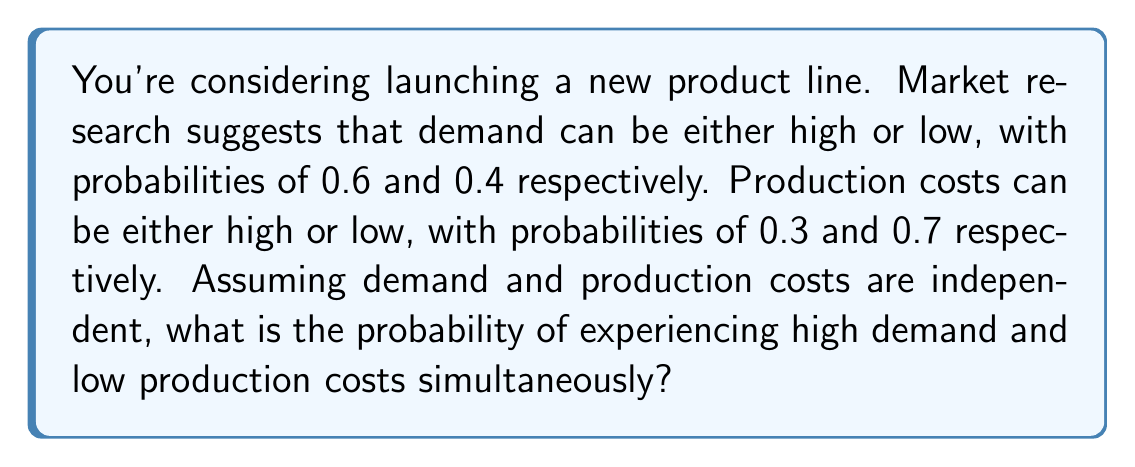Give your solution to this math problem. To solve this problem, we need to use the concept of joint probability for independent events. Let's approach this step-by-step:

1. Define the events:
   - Let H be the event of high demand
   - Let L be the event of low production costs

2. Given probabilities:
   - P(H) = 0.6 (probability of high demand)
   - P(L) = 0.7 (probability of low production costs)

3. Since the events are independent, the joint probability is the product of their individual probabilities:

   $$P(H \text{ and } L) = P(H) \times P(L)$$

4. Substitute the values:

   $$P(H \text{ and } L) = 0.6 \times 0.7$$

5. Calculate:

   $$P(H \text{ and } L) = 0.42$$

Therefore, the probability of experiencing high demand and low production costs simultaneously is 0.42 or 42%.
Answer: 0.42 